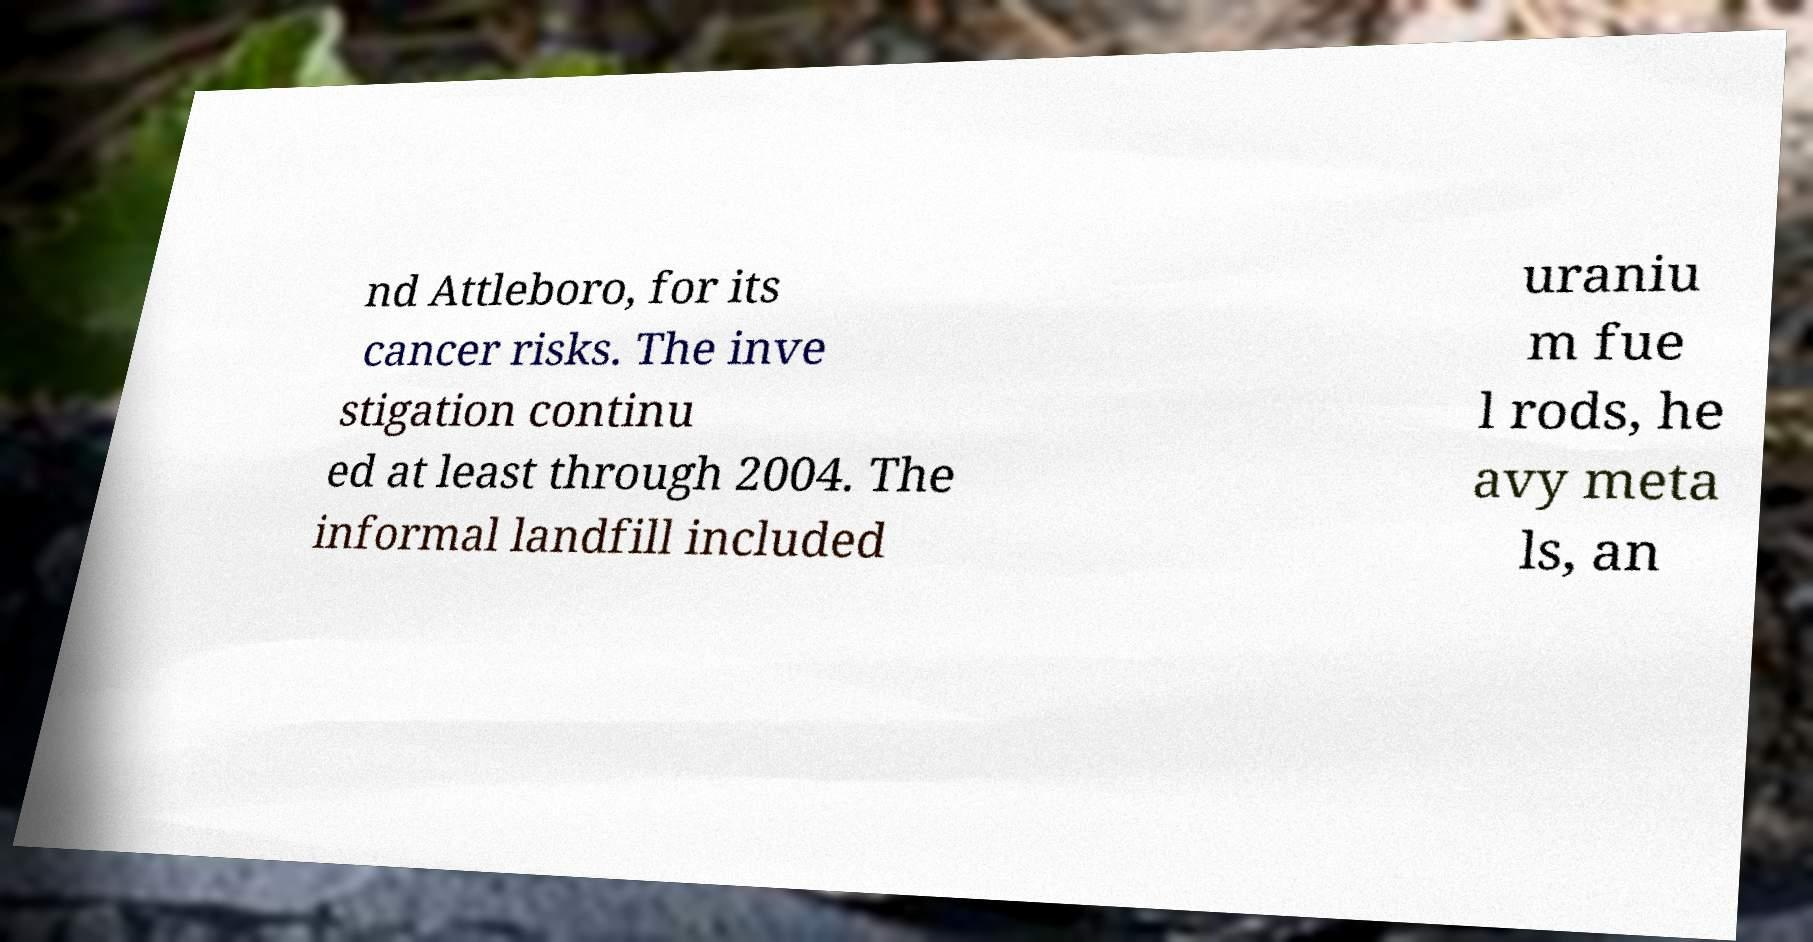Could you extract and type out the text from this image? nd Attleboro, for its cancer risks. The inve stigation continu ed at least through 2004. The informal landfill included uraniu m fue l rods, he avy meta ls, an 